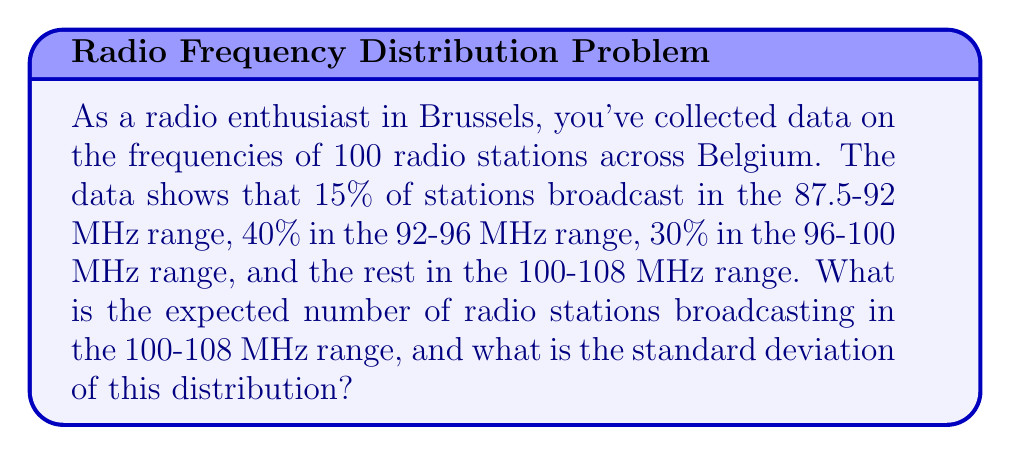Can you solve this math problem? Let's approach this step-by-step:

1) First, we need to calculate the percentage of stations in the 100-108 MHz range:
   100% - (15% + 40% + 30%) = 15%

2) Now, we can calculate the expected number of stations in this range:
   $E(X) = np = 100 \times 0.15 = 15$ stations

3) To calculate the standard deviation, we'll use the formula for a binomial distribution:
   $\sigma = \sqrt{np(1-p)}$

   Where:
   $n = 100$ (total number of stations)
   $p = 0.15$ (probability of a station being in the 100-108 MHz range)

4) Plugging in the values:
   $\sigma = \sqrt{100 \times 0.15 \times (1-0.15)}$
   $\sigma = \sqrt{100 \times 0.15 \times 0.85}$
   $\sigma = \sqrt{12.75}$
   $\sigma \approx 3.57$

5) Rounding to two decimal places:
   $\sigma \approx 3.57$

Therefore, the expected number of stations in the 100-108 MHz range is 15, and the standard deviation is approximately 3.57.
Answer: Expected number: 15, Standard deviation: 3.57 